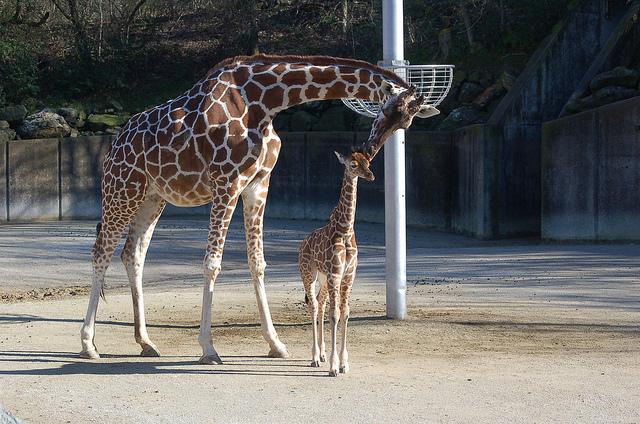What is the baby giraffe doing?
Write a very short answer. Standing. Is this a baby giraffe?
Be succinct. Yes. What material is the wall made of?
Quick response, please. Concrete. Of the two giraffes in the photo, is the one on the right taller or shorter?
Keep it brief. Shorter. What is the giraffe doing?
Quick response, please. Licking baby. Is this giraffe alone?
Keep it brief. No. How many legs are visible?
Answer briefly. 8. Do these animals lie down to sleep?
Short answer required. Yes. Is this giraffe poking its head in a cave?
Quick response, please. No. What are the giraffes doing?
Keep it brief. Standing. What is the small animal?
Quick response, please. Giraffe. What does the giraffe in the foreground appear to be doing?
Concise answer only. Standing. 